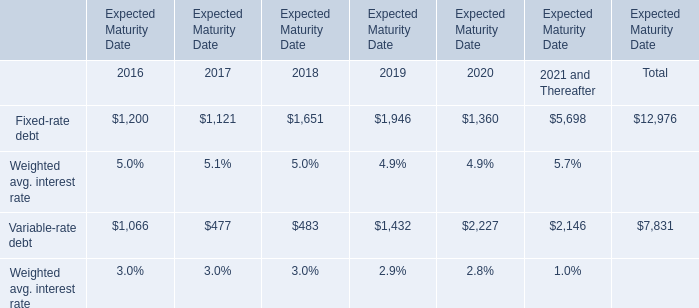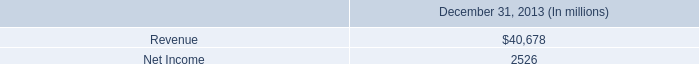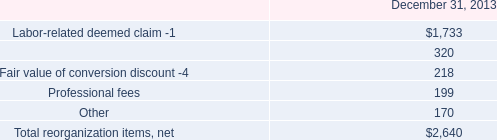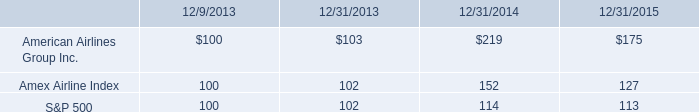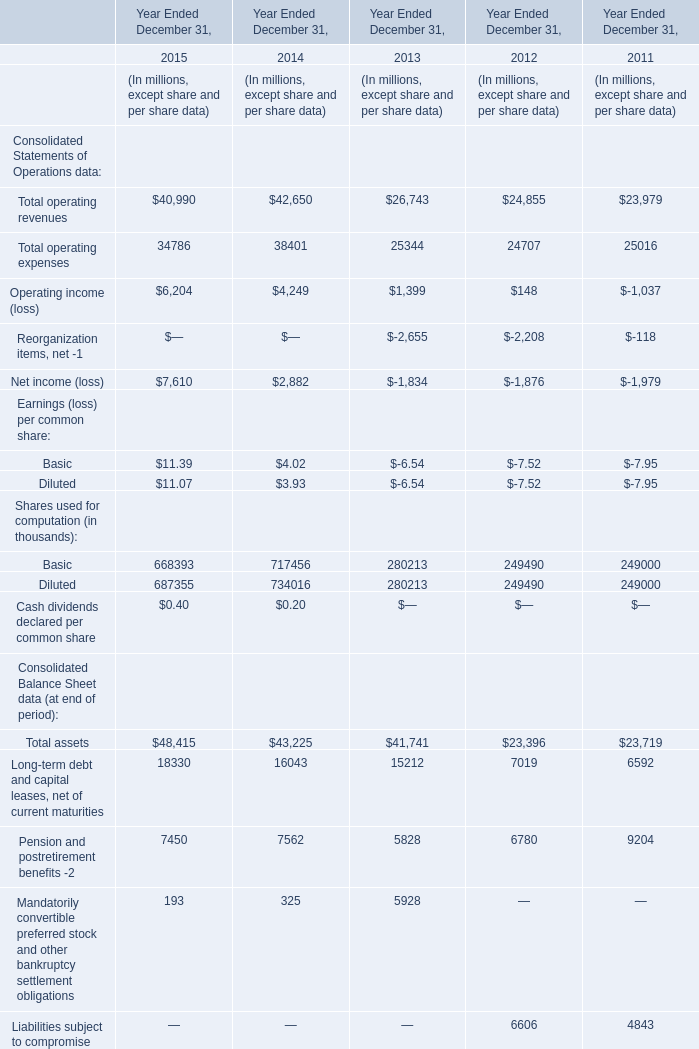what was the rate of growth or decrease from 2014 to 2015 on the american airlines group inc . 
Computations: ((175 - 219) / 219)
Answer: -0.20091. 